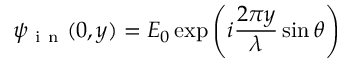Convert formula to latex. <formula><loc_0><loc_0><loc_500><loc_500>\psi _ { i n } ( 0 , y ) = E _ { 0 } \exp \left ( i \frac { 2 \pi y } { \lambda } \sin \theta \right )</formula> 